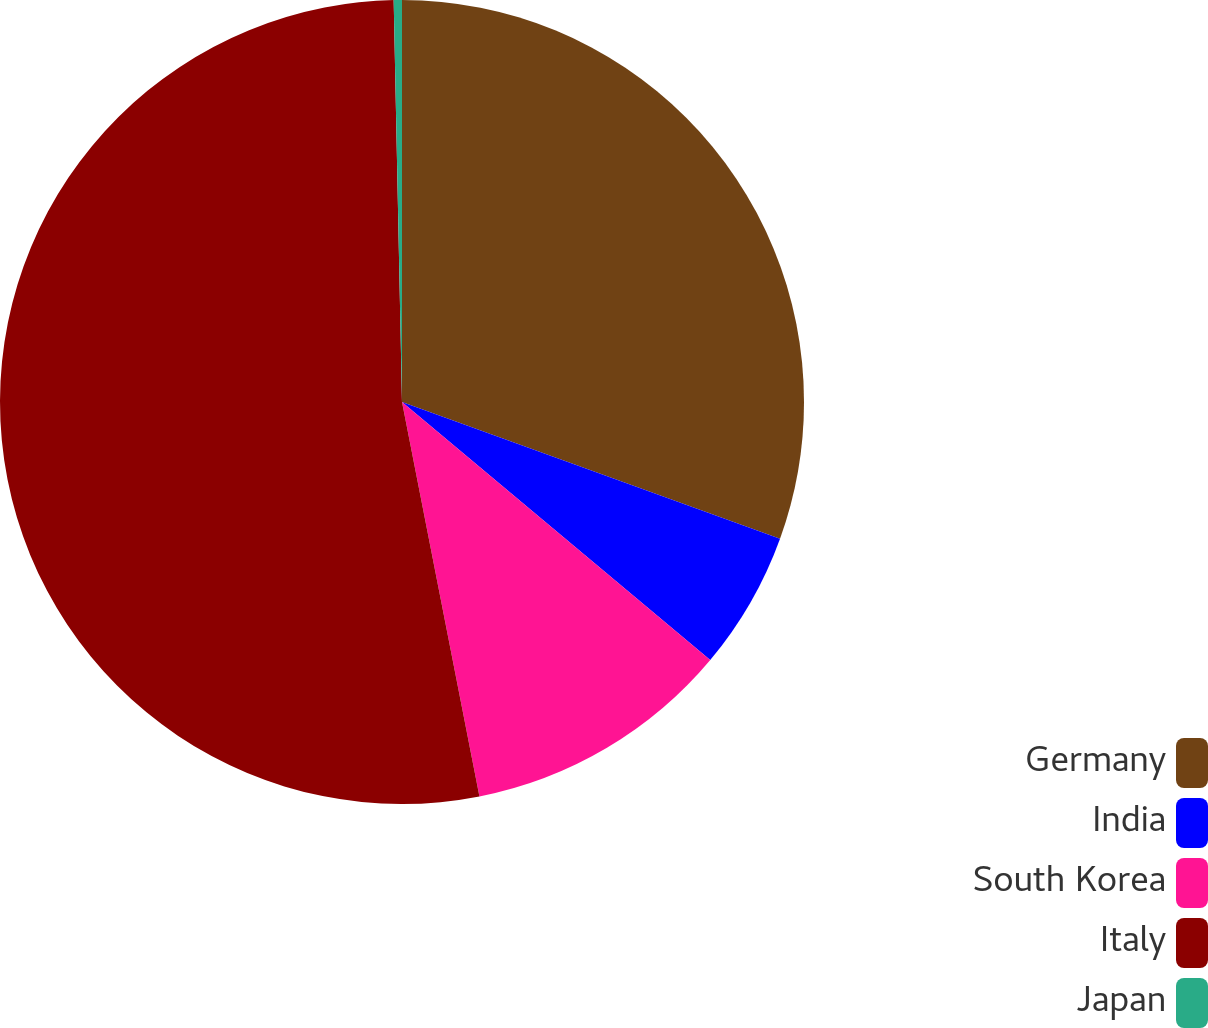Convert chart to OTSL. <chart><loc_0><loc_0><loc_500><loc_500><pie_chart><fcel>Germany<fcel>India<fcel>South Korea<fcel>Italy<fcel>Japan<nl><fcel>30.52%<fcel>5.57%<fcel>10.82%<fcel>52.75%<fcel>0.33%<nl></chart> 